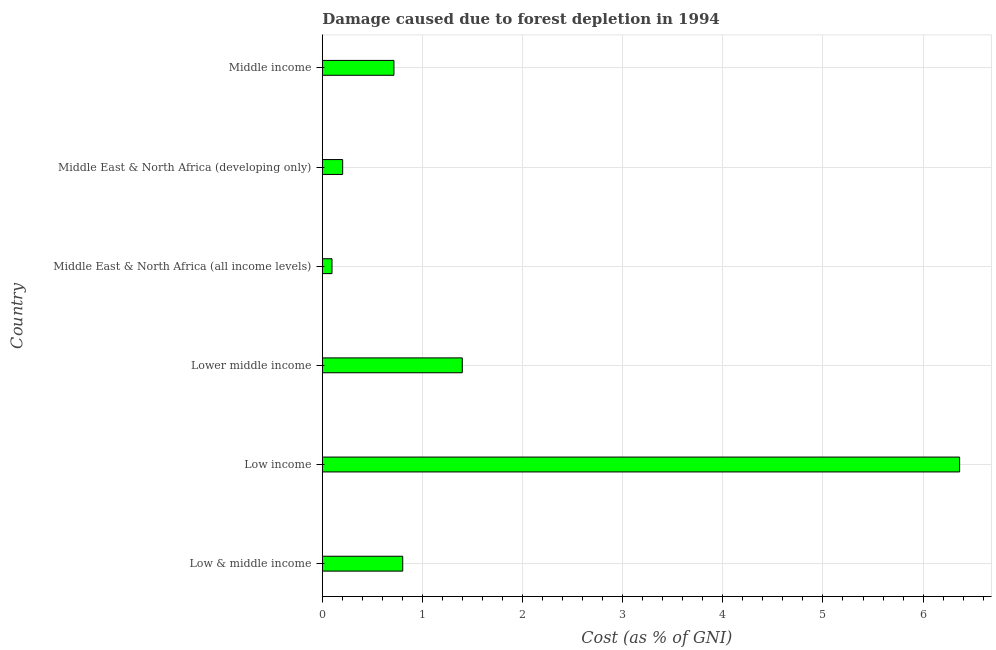Does the graph contain any zero values?
Offer a terse response. No. What is the title of the graph?
Ensure brevity in your answer.  Damage caused due to forest depletion in 1994. What is the label or title of the X-axis?
Provide a short and direct response. Cost (as % of GNI). What is the label or title of the Y-axis?
Provide a short and direct response. Country. What is the damage caused due to forest depletion in Low & middle income?
Your response must be concise. 0.8. Across all countries, what is the maximum damage caused due to forest depletion?
Ensure brevity in your answer.  6.36. Across all countries, what is the minimum damage caused due to forest depletion?
Your answer should be compact. 0.1. In which country was the damage caused due to forest depletion minimum?
Offer a terse response. Middle East & North Africa (all income levels). What is the sum of the damage caused due to forest depletion?
Provide a succinct answer. 9.58. What is the difference between the damage caused due to forest depletion in Low & middle income and Low income?
Your answer should be compact. -5.56. What is the average damage caused due to forest depletion per country?
Provide a succinct answer. 1.6. What is the median damage caused due to forest depletion?
Provide a short and direct response. 0.76. What is the ratio of the damage caused due to forest depletion in Middle East & North Africa (all income levels) to that in Middle East & North Africa (developing only)?
Ensure brevity in your answer.  0.48. What is the difference between the highest and the second highest damage caused due to forest depletion?
Offer a very short reply. 4.97. What is the difference between the highest and the lowest damage caused due to forest depletion?
Provide a short and direct response. 6.27. In how many countries, is the damage caused due to forest depletion greater than the average damage caused due to forest depletion taken over all countries?
Provide a short and direct response. 1. How many bars are there?
Provide a short and direct response. 6. How many countries are there in the graph?
Make the answer very short. 6. Are the values on the major ticks of X-axis written in scientific E-notation?
Make the answer very short. No. What is the Cost (as % of GNI) of Low & middle income?
Your answer should be very brief. 0.8. What is the Cost (as % of GNI) in Low income?
Provide a succinct answer. 6.36. What is the Cost (as % of GNI) of Lower middle income?
Your answer should be very brief. 1.4. What is the Cost (as % of GNI) in Middle East & North Africa (all income levels)?
Your response must be concise. 0.1. What is the Cost (as % of GNI) in Middle East & North Africa (developing only)?
Provide a succinct answer. 0.2. What is the Cost (as % of GNI) of Middle income?
Provide a short and direct response. 0.72. What is the difference between the Cost (as % of GNI) in Low & middle income and Low income?
Provide a succinct answer. -5.56. What is the difference between the Cost (as % of GNI) in Low & middle income and Lower middle income?
Keep it short and to the point. -0.59. What is the difference between the Cost (as % of GNI) in Low & middle income and Middle East & North Africa (all income levels)?
Offer a very short reply. 0.71. What is the difference between the Cost (as % of GNI) in Low & middle income and Middle East & North Africa (developing only)?
Give a very brief answer. 0.6. What is the difference between the Cost (as % of GNI) in Low & middle income and Middle income?
Your answer should be very brief. 0.09. What is the difference between the Cost (as % of GNI) in Low income and Lower middle income?
Your answer should be very brief. 4.97. What is the difference between the Cost (as % of GNI) in Low income and Middle East & North Africa (all income levels)?
Your answer should be very brief. 6.27. What is the difference between the Cost (as % of GNI) in Low income and Middle East & North Africa (developing only)?
Offer a very short reply. 6.16. What is the difference between the Cost (as % of GNI) in Low income and Middle income?
Give a very brief answer. 5.65. What is the difference between the Cost (as % of GNI) in Lower middle income and Middle East & North Africa (all income levels)?
Ensure brevity in your answer.  1.3. What is the difference between the Cost (as % of GNI) in Lower middle income and Middle East & North Africa (developing only)?
Provide a short and direct response. 1.19. What is the difference between the Cost (as % of GNI) in Lower middle income and Middle income?
Your response must be concise. 0.68. What is the difference between the Cost (as % of GNI) in Middle East & North Africa (all income levels) and Middle East & North Africa (developing only)?
Provide a succinct answer. -0.11. What is the difference between the Cost (as % of GNI) in Middle East & North Africa (all income levels) and Middle income?
Offer a terse response. -0.62. What is the difference between the Cost (as % of GNI) in Middle East & North Africa (developing only) and Middle income?
Give a very brief answer. -0.51. What is the ratio of the Cost (as % of GNI) in Low & middle income to that in Low income?
Offer a very short reply. 0.13. What is the ratio of the Cost (as % of GNI) in Low & middle income to that in Lower middle income?
Keep it short and to the point. 0.57. What is the ratio of the Cost (as % of GNI) in Low & middle income to that in Middle East & North Africa (all income levels)?
Your answer should be compact. 8.31. What is the ratio of the Cost (as % of GNI) in Low & middle income to that in Middle East & North Africa (developing only)?
Give a very brief answer. 3.95. What is the ratio of the Cost (as % of GNI) in Low & middle income to that in Middle income?
Offer a very short reply. 1.12. What is the ratio of the Cost (as % of GNI) in Low income to that in Lower middle income?
Your response must be concise. 4.55. What is the ratio of the Cost (as % of GNI) in Low income to that in Middle East & North Africa (all income levels)?
Your answer should be very brief. 65.86. What is the ratio of the Cost (as % of GNI) in Low income to that in Middle East & North Africa (developing only)?
Offer a very short reply. 31.34. What is the ratio of the Cost (as % of GNI) in Low income to that in Middle income?
Your answer should be compact. 8.9. What is the ratio of the Cost (as % of GNI) in Lower middle income to that in Middle East & North Africa (all income levels)?
Your response must be concise. 14.46. What is the ratio of the Cost (as % of GNI) in Lower middle income to that in Middle East & North Africa (developing only)?
Provide a succinct answer. 6.88. What is the ratio of the Cost (as % of GNI) in Lower middle income to that in Middle income?
Keep it short and to the point. 1.95. What is the ratio of the Cost (as % of GNI) in Middle East & North Africa (all income levels) to that in Middle East & North Africa (developing only)?
Your answer should be very brief. 0.48. What is the ratio of the Cost (as % of GNI) in Middle East & North Africa (all income levels) to that in Middle income?
Your response must be concise. 0.14. What is the ratio of the Cost (as % of GNI) in Middle East & North Africa (developing only) to that in Middle income?
Your answer should be very brief. 0.28. 